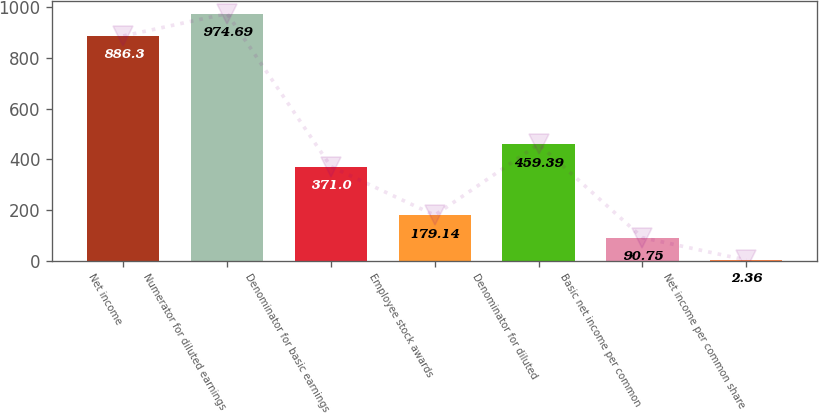Convert chart. <chart><loc_0><loc_0><loc_500><loc_500><bar_chart><fcel>Net income<fcel>Numerator for diluted earnings<fcel>Denominator for basic earnings<fcel>Employee stock awards<fcel>Denominator for diluted<fcel>Basic net income per common<fcel>Net income per common share<nl><fcel>886.3<fcel>974.69<fcel>371<fcel>179.14<fcel>459.39<fcel>90.75<fcel>2.36<nl></chart> 